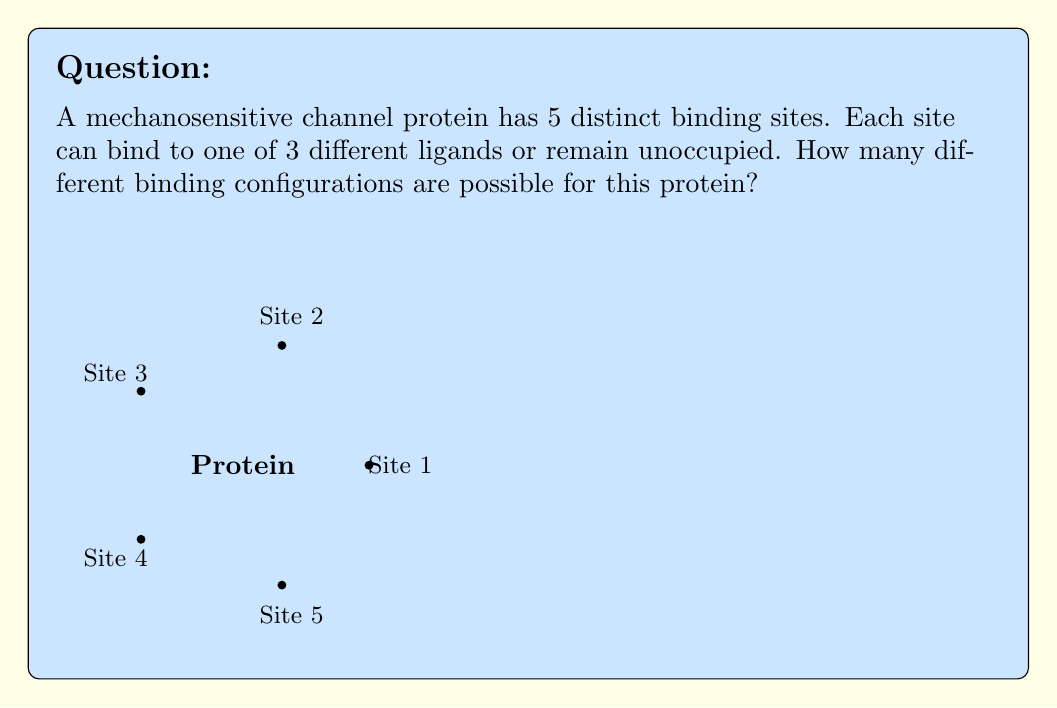Teach me how to tackle this problem. Let's approach this step-by-step:

1) First, we need to understand what the question is asking. For each binding site, we have 4 possibilities:
   - It can be unoccupied
   - It can bind to ligand 1
   - It can bind to ligand 2
   - It can bind to ligand 3

2) This is a case of independent events. The binding state of one site doesn't affect the others.

3) For each site, we have 4 choices. There are 5 sites in total.

4) When we have a series of independent choices, we multiply the number of possibilities for each choice.

5) Therefore, the total number of configurations is:

   $$ 4 \times 4 \times 4 \times 4 \times 4 = 4^5 $$

6) We can calculate this:
   $$ 4^5 = 4 \times 4 \times 4 \times 4 \times 4 = 1024 $$

This result represents all possible combinations of occupied and unoccupied states across all five binding sites.
Answer: 1024 